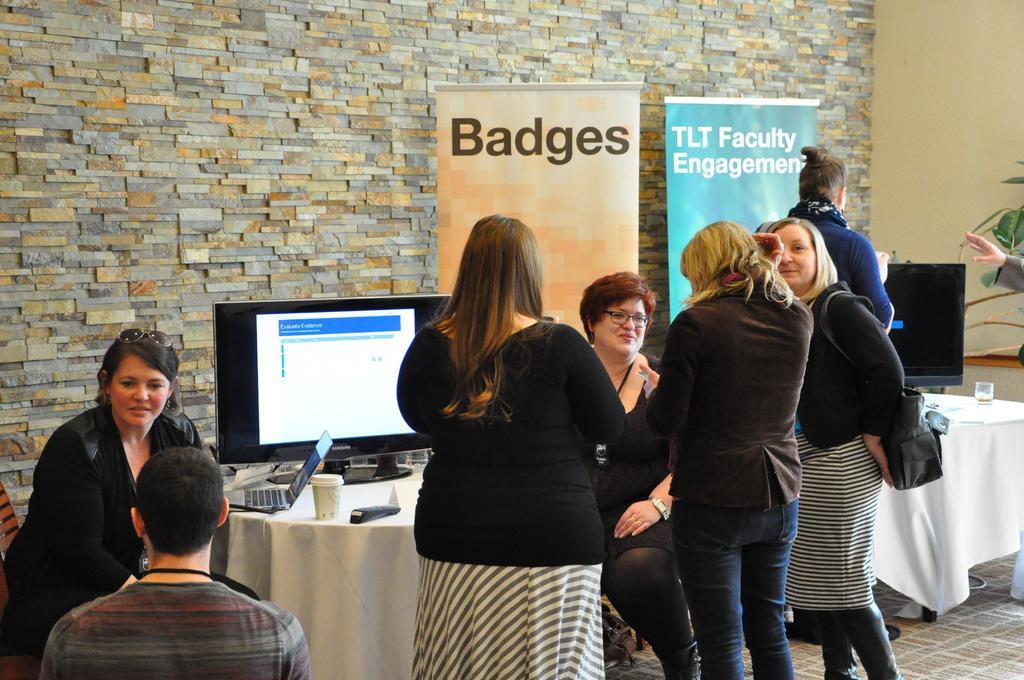In one or two sentences, can you explain what this image depicts? In the image there are few ladies. Behind them there are tables with monitors, laptop, cup and few other items. And also there are posters. In the background there is a wall. On the right side of the image there are leaves. 